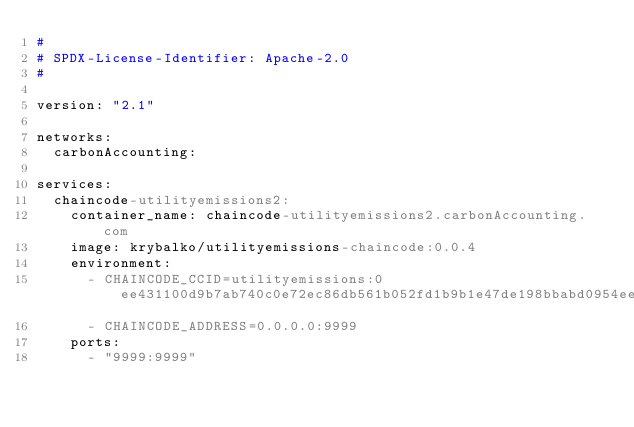<code> <loc_0><loc_0><loc_500><loc_500><_YAML_>#
# SPDX-License-Identifier: Apache-2.0
#

version: "2.1"

networks:
  carbonAccounting:

services:
  chaincode-utilityemissions2:
    container_name: chaincode-utilityemissions2.carbonAccounting.com
    image: krybalko/utilityemissions-chaincode:0.0.4
    environment:
      - CHAINCODE_CCID=utilityemissions:0ee431100d9b7ab740c0e72ec86db561b052fd1b9b1e47de198bbabd0954ee97
      - CHAINCODE_ADDRESS=0.0.0.0:9999
    ports:
      - "9999:9999"
</code> 